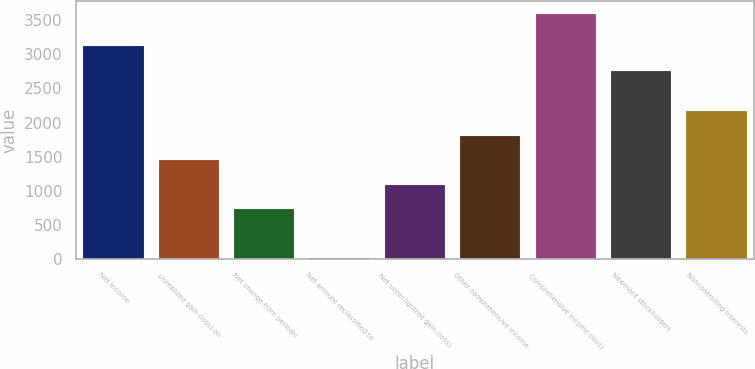Convert chart to OTSL. <chart><loc_0><loc_0><loc_500><loc_500><bar_chart><fcel>Net income<fcel>Unrealized gain (loss) on<fcel>Net change from periodic<fcel>Net amount reclassified to<fcel>Net unrecognized gain (loss)<fcel>Other comprehensive income<fcel>Comprehensive income (loss)<fcel>Newmont stockholders<fcel>Noncontrolling interests<nl><fcel>3118<fcel>1446<fcel>728<fcel>10<fcel>1087<fcel>1805<fcel>3600<fcel>2759<fcel>2164<nl></chart> 